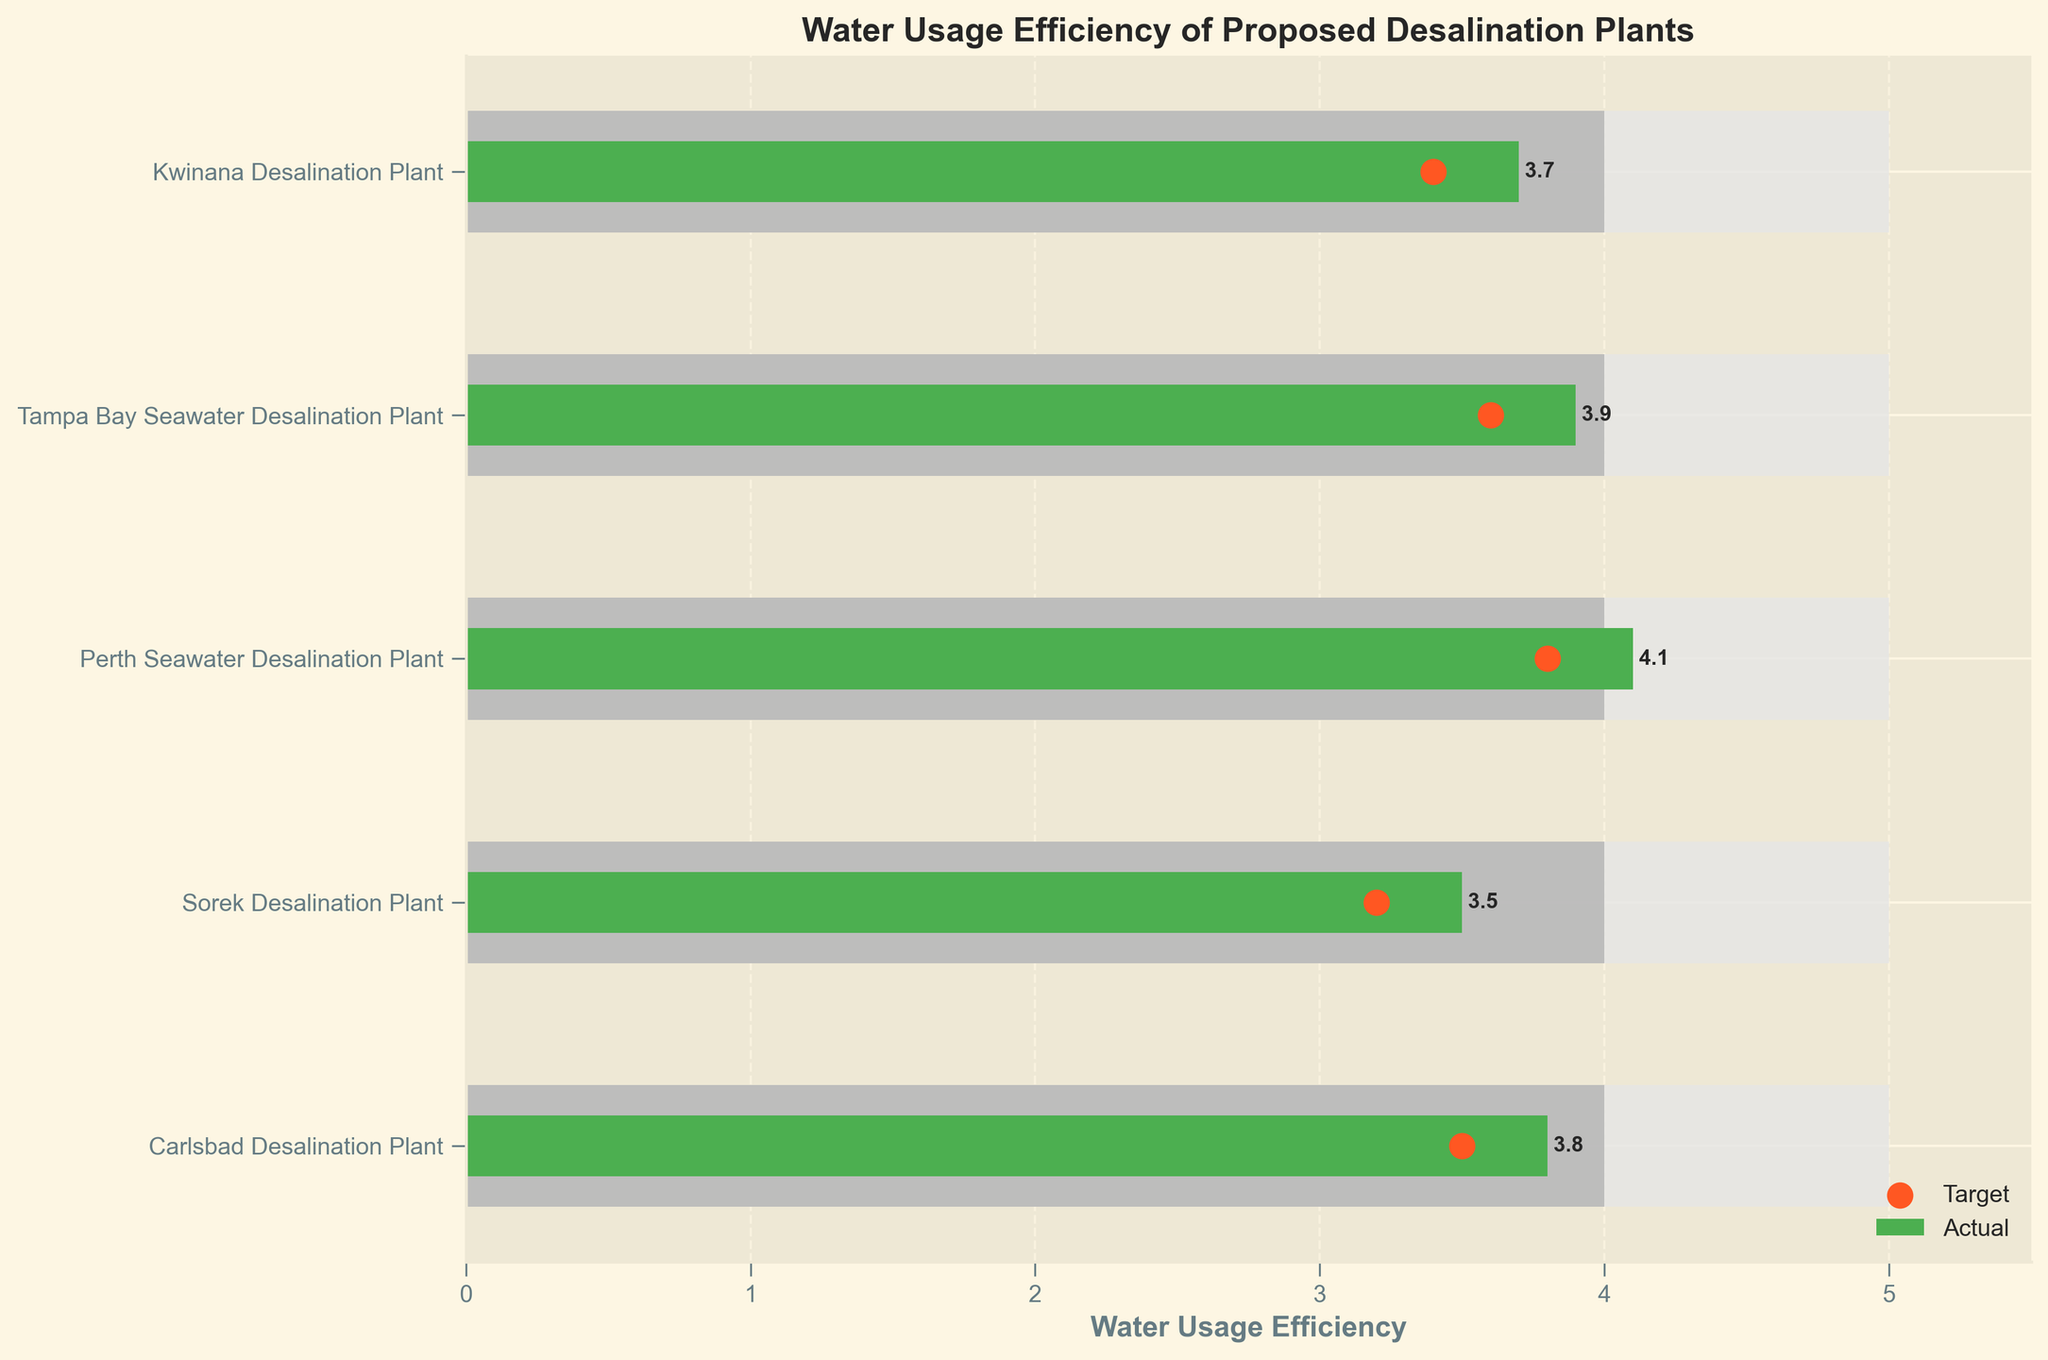What is the title of the figure? The title of the figure is normally found at the top of the plot, summarizing the main subject or variable being presented.
Answer: Water Usage Efficiency of Proposed Desalination Plants What is the range of water usage efficiency values displayed on the x-axis? The x-axis range shows the minimum and maximum values of water usage efficiency measurements presented in the figure. Based on the data, the maximum efficiency is 5.0, and the x-axis is set a little higher to 5.5 in the figure.
Answer: 0 to 5.5 Which project has the highest actual water usage efficiency? To find this, look at the green bars representing actual values and identify the longest one.
Answer: Perth Seawater Desalination Plant How do the actual and target water usage efficiencies compare for the Carlsbad Desalination Plant? Compare the green bar representing actual efficiency with the orange dots representing target efficiency for the Carlsbad Desalination Plant. The actual value is 3.8, while the target is 3.5.
Answer: The actual efficiency is higher than the target Which desalination plant has its actual water usage efficiency closest to its target? Calculate the absolute difference between the actual values (green bars) and target values (orange dots) for each plant and find the smallest difference.
Answer: Sorek Desalination Plant By how much does the Perth Seawater Desalination Plant's actual efficiency exceed the industry benchmark? Subtract the industry benchmark value (gray bar) from the actual value (green bar) for the Perth Seawater Desalination Plant. 4.1 (actual) - 4.0 (benchmark) = 0.1
Answer: 0.1 Are any projects below their industry benchmark in actual water usage efficiency? Compare the green bars (actual values) to the gray bars (benchmark) for all projects. None of the green bars are shorter than the respective gray bars.
Answer: No Which project has the smallest gap between its actual and maximum efficiency? Calculate the difference between actual efficiency (green bar) and maximum efficiency (white bar) for each project and identify the smallest gap.
Answer: Sorek Desalination Plant How many data points are presented in the figure? Count the number of unique projects listed on the y-axis or the number of bars on the chart.
Answer: 5 What is the industry benchmark for water usage efficiency for these desalination plants? Look for the gray bars which represent the industry benchmark value indicated in the legend.
Answer: 4.0 